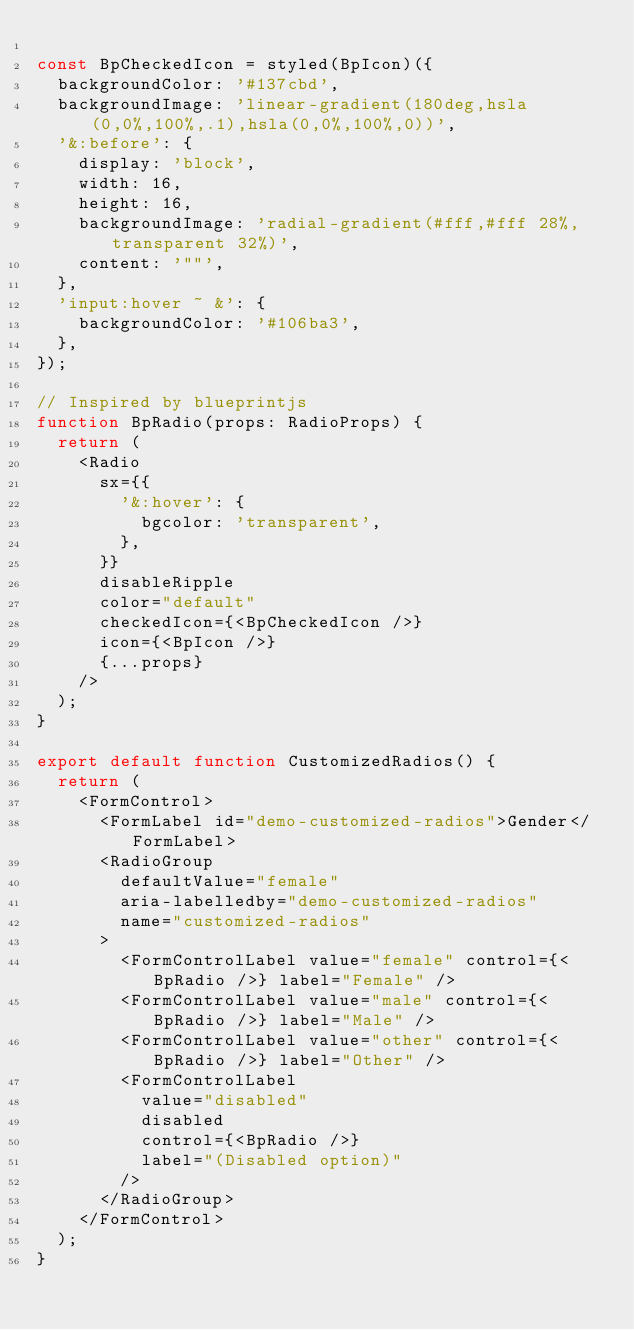<code> <loc_0><loc_0><loc_500><loc_500><_TypeScript_>
const BpCheckedIcon = styled(BpIcon)({
  backgroundColor: '#137cbd',
  backgroundImage: 'linear-gradient(180deg,hsla(0,0%,100%,.1),hsla(0,0%,100%,0))',
  '&:before': {
    display: 'block',
    width: 16,
    height: 16,
    backgroundImage: 'radial-gradient(#fff,#fff 28%,transparent 32%)',
    content: '""',
  },
  'input:hover ~ &': {
    backgroundColor: '#106ba3',
  },
});

// Inspired by blueprintjs
function BpRadio(props: RadioProps) {
  return (
    <Radio
      sx={{
        '&:hover': {
          bgcolor: 'transparent',
        },
      }}
      disableRipple
      color="default"
      checkedIcon={<BpCheckedIcon />}
      icon={<BpIcon />}
      {...props}
    />
  );
}

export default function CustomizedRadios() {
  return (
    <FormControl>
      <FormLabel id="demo-customized-radios">Gender</FormLabel>
      <RadioGroup
        defaultValue="female"
        aria-labelledby="demo-customized-radios"
        name="customized-radios"
      >
        <FormControlLabel value="female" control={<BpRadio />} label="Female" />
        <FormControlLabel value="male" control={<BpRadio />} label="Male" />
        <FormControlLabel value="other" control={<BpRadio />} label="Other" />
        <FormControlLabel
          value="disabled"
          disabled
          control={<BpRadio />}
          label="(Disabled option)"
        />
      </RadioGroup>
    </FormControl>
  );
}
</code> 